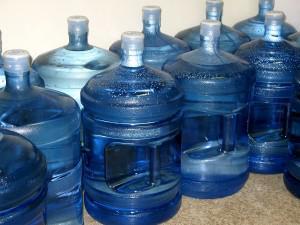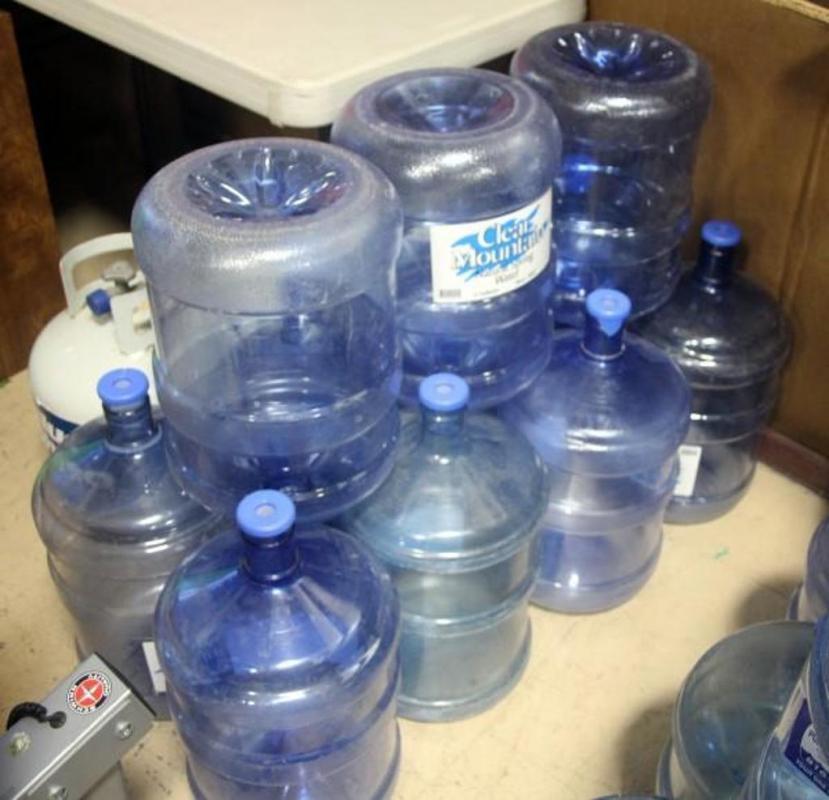The first image is the image on the left, the second image is the image on the right. Considering the images on both sides, is "An image shows at least one water jug stacked inverted on upright jugs." valid? Answer yes or no. Yes. The first image is the image on the left, the second image is the image on the right. Analyze the images presented: Is the assertion "There are more than three water containers standing up." valid? Answer yes or no. Yes. 